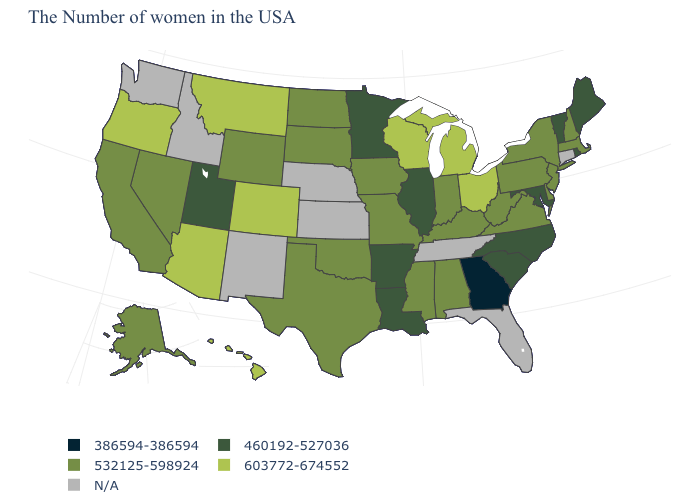What is the value of Maryland?
Quick response, please. 460192-527036. What is the value of Oklahoma?
Concise answer only. 532125-598924. Which states have the lowest value in the USA?
Be succinct. Georgia. Is the legend a continuous bar?
Write a very short answer. No. What is the lowest value in the USA?
Keep it brief. 386594-386594. Name the states that have a value in the range 532125-598924?
Answer briefly. Massachusetts, New Hampshire, New York, New Jersey, Delaware, Pennsylvania, Virginia, West Virginia, Kentucky, Indiana, Alabama, Mississippi, Missouri, Iowa, Oklahoma, Texas, South Dakota, North Dakota, Wyoming, Nevada, California, Alaska. What is the value of Nevada?
Answer briefly. 532125-598924. Name the states that have a value in the range 460192-527036?
Concise answer only. Maine, Rhode Island, Vermont, Maryland, North Carolina, South Carolina, Illinois, Louisiana, Arkansas, Minnesota, Utah. Name the states that have a value in the range 603772-674552?
Give a very brief answer. Ohio, Michigan, Wisconsin, Colorado, Montana, Arizona, Oregon, Hawaii. Does South Dakota have the highest value in the MidWest?
Be succinct. No. Does Indiana have the highest value in the USA?
Write a very short answer. No. What is the value of Ohio?
Be succinct. 603772-674552. Among the states that border North Carolina , does Virginia have the highest value?
Keep it brief. Yes. Name the states that have a value in the range 386594-386594?
Keep it brief. Georgia. What is the value of Virginia?
Concise answer only. 532125-598924. 